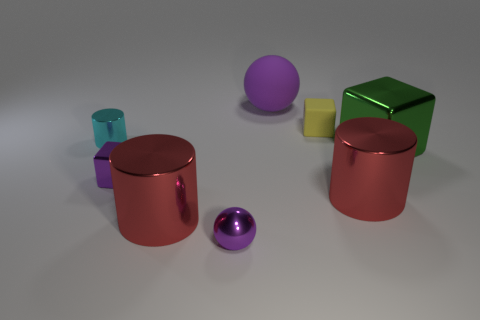Can you describe the sizes of the objects in relation to each other? Certainly! The two red cylinders appear to be the largest objects in the scene. The green cube is slightly smaller in comparison, followed by the purple sphere. The yellow cube is noticeably smaller than the other objects, and the small cyan and purple spheres are the smallest items present. 